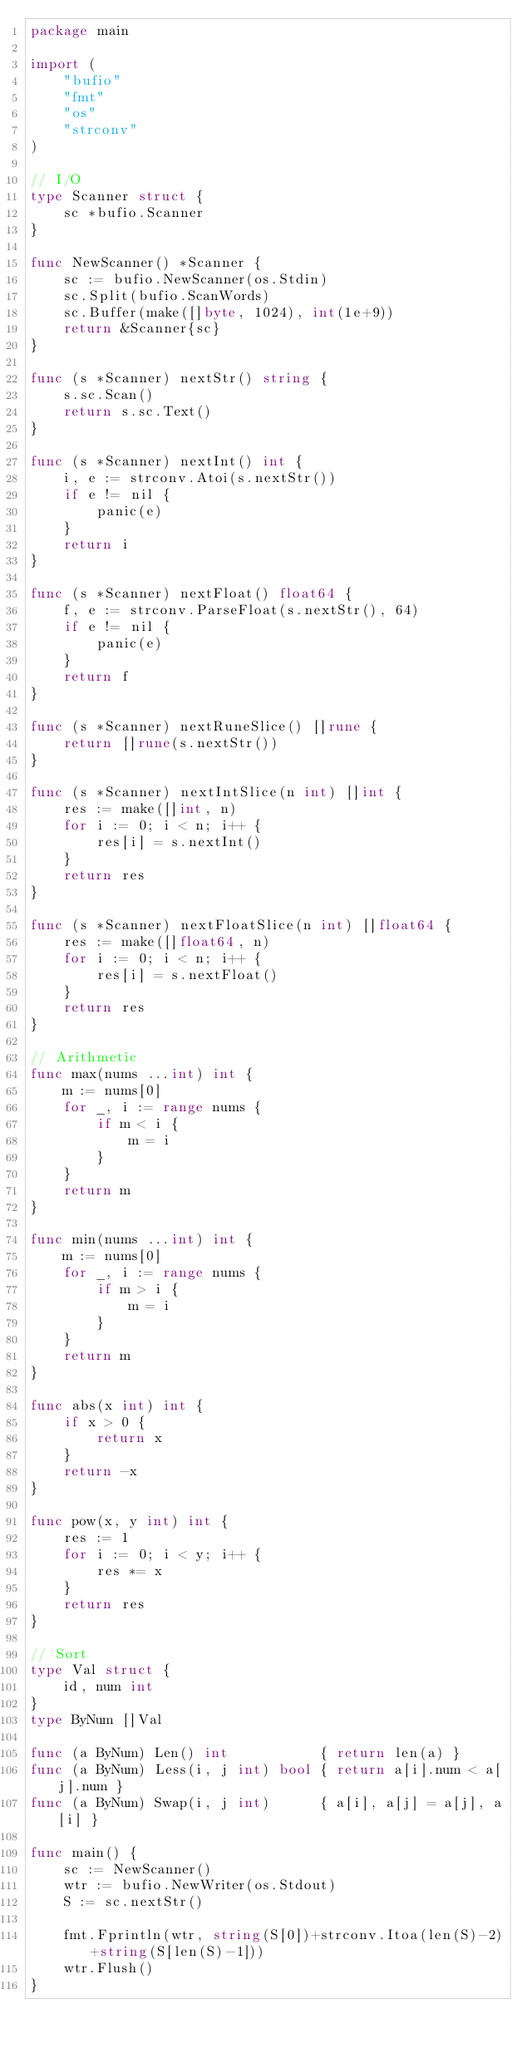Convert code to text. <code><loc_0><loc_0><loc_500><loc_500><_Go_>package main

import (
	"bufio"
	"fmt"
	"os"
	"strconv"
)

// I/O
type Scanner struct {
	sc *bufio.Scanner
}

func NewScanner() *Scanner {
	sc := bufio.NewScanner(os.Stdin)
	sc.Split(bufio.ScanWords)
	sc.Buffer(make([]byte, 1024), int(1e+9))
	return &Scanner{sc}
}

func (s *Scanner) nextStr() string {
	s.sc.Scan()
	return s.sc.Text()
}

func (s *Scanner) nextInt() int {
	i, e := strconv.Atoi(s.nextStr())
	if e != nil {
		panic(e)
	}
	return i
}

func (s *Scanner) nextFloat() float64 {
	f, e := strconv.ParseFloat(s.nextStr(), 64)
	if e != nil {
		panic(e)
	}
	return f
}

func (s *Scanner) nextRuneSlice() []rune {
	return []rune(s.nextStr())
}

func (s *Scanner) nextIntSlice(n int) []int {
	res := make([]int, n)
	for i := 0; i < n; i++ {
		res[i] = s.nextInt()
	}
	return res
}

func (s *Scanner) nextFloatSlice(n int) []float64 {
	res := make([]float64, n)
	for i := 0; i < n; i++ {
		res[i] = s.nextFloat()
	}
	return res
}

// Arithmetic
func max(nums ...int) int {
	m := nums[0]
	for _, i := range nums {
		if m < i {
			m = i
		}
	}
	return m
}

func min(nums ...int) int {
	m := nums[0]
	for _, i := range nums {
		if m > i {
			m = i
		}
	}
	return m
}

func abs(x int) int {
	if x > 0 {
		return x
	}
	return -x
}

func pow(x, y int) int {
	res := 1
	for i := 0; i < y; i++ {
		res *= x
	}
	return res
}

// Sort
type Val struct {
	id, num int
}
type ByNum []Val

func (a ByNum) Len() int           { return len(a) }
func (a ByNum) Less(i, j int) bool { return a[i].num < a[j].num }
func (a ByNum) Swap(i, j int)      { a[i], a[j] = a[j], a[i] }

func main() {
	sc := NewScanner()
	wtr := bufio.NewWriter(os.Stdout)
	S := sc.nextStr()

	fmt.Fprintln(wtr, string(S[0])+strconv.Itoa(len(S)-2)+string(S[len(S)-1]))
	wtr.Flush()
}
</code> 